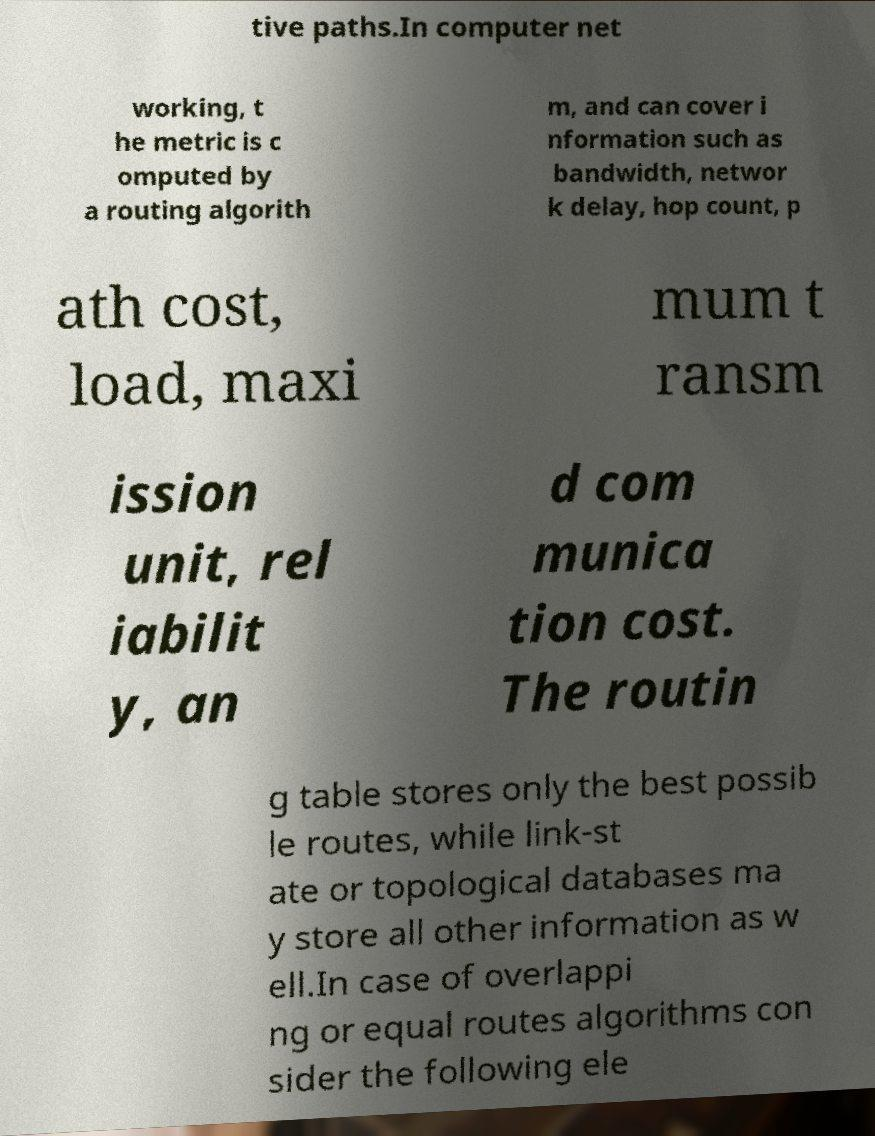Could you assist in decoding the text presented in this image and type it out clearly? tive paths.In computer net working, t he metric is c omputed by a routing algorith m, and can cover i nformation such as bandwidth, networ k delay, hop count, p ath cost, load, maxi mum t ransm ission unit, rel iabilit y, an d com munica tion cost. The routin g table stores only the best possib le routes, while link-st ate or topological databases ma y store all other information as w ell.In case of overlappi ng or equal routes algorithms con sider the following ele 